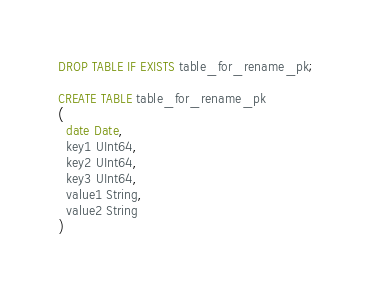Convert code to text. <code><loc_0><loc_0><loc_500><loc_500><_SQL_>DROP TABLE IF EXISTS table_for_rename_pk;

CREATE TABLE table_for_rename_pk
(
  date Date,
  key1 UInt64,
  key2 UInt64,
  key3 UInt64,
  value1 String,
  value2 String
)</code> 